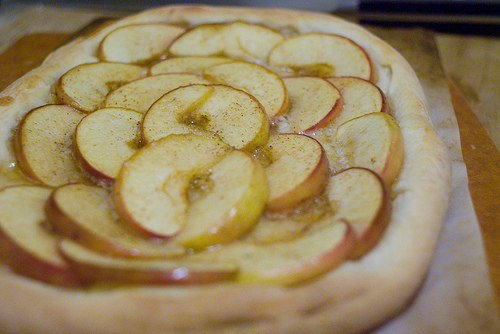<image>
Can you confirm if the bread is to the right of the apples? No. The bread is not to the right of the apples. The horizontal positioning shows a different relationship. 